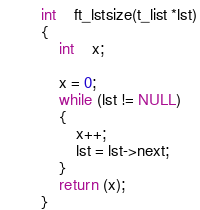<code> <loc_0><loc_0><loc_500><loc_500><_C_>
int	ft_lstsize(t_list *lst)
{
	int	x;

	x = 0;
	while (lst != NULL)
	{
		x++;
		lst = lst->next;
	}
	return (x);
}
</code> 